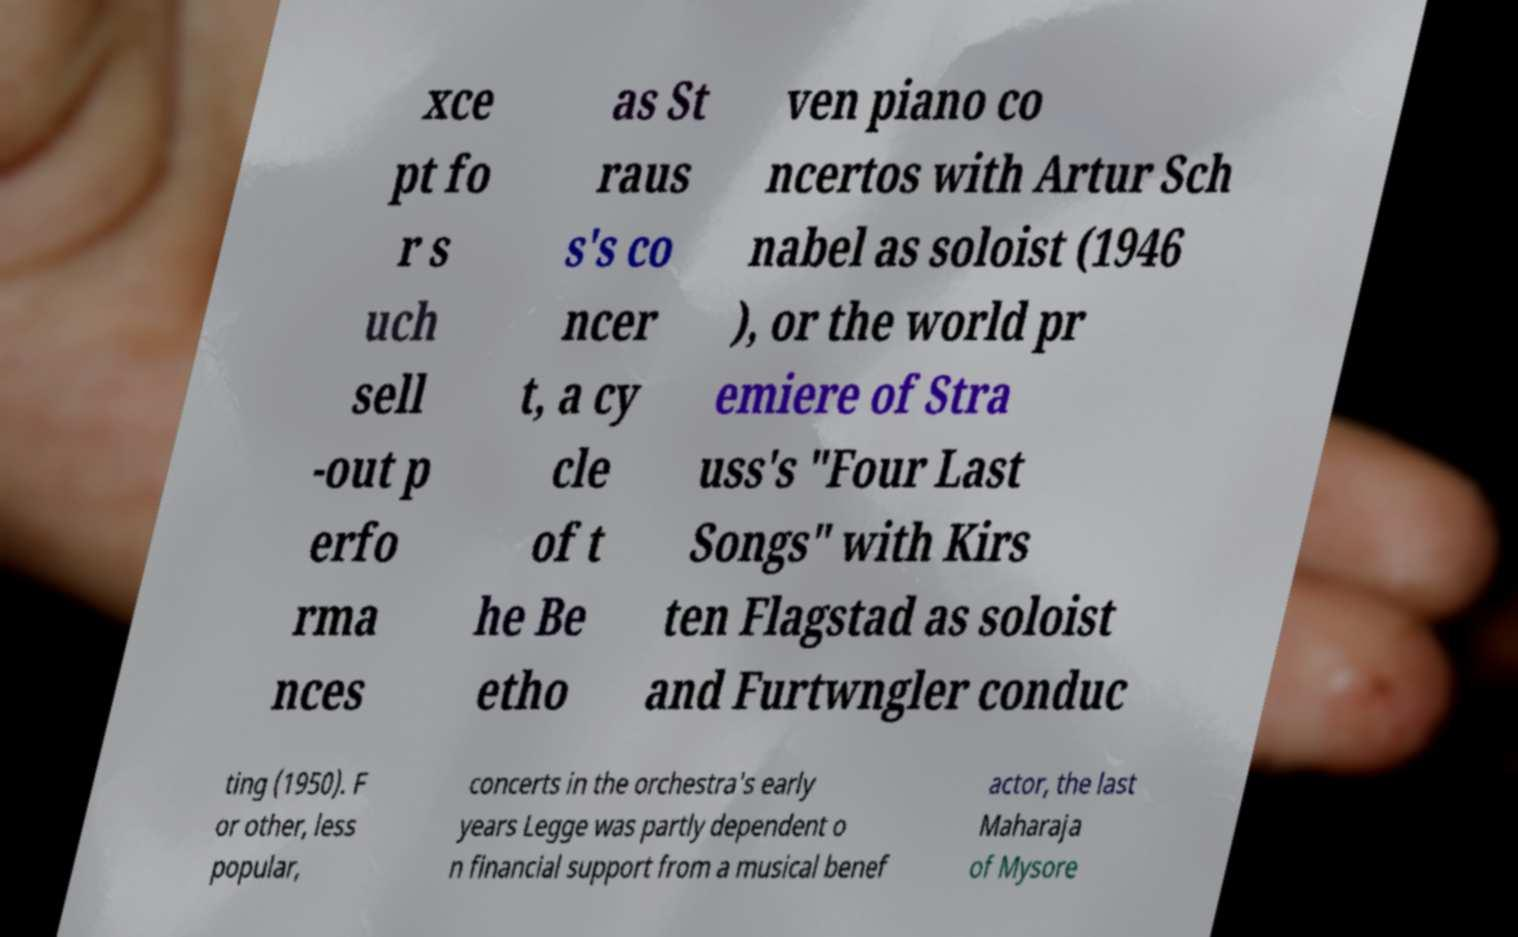There's text embedded in this image that I need extracted. Can you transcribe it verbatim? xce pt fo r s uch sell -out p erfo rma nces as St raus s's co ncer t, a cy cle of t he Be etho ven piano co ncertos with Artur Sch nabel as soloist (1946 ), or the world pr emiere of Stra uss's "Four Last Songs" with Kirs ten Flagstad as soloist and Furtwngler conduc ting (1950). F or other, less popular, concerts in the orchestra's early years Legge was partly dependent o n financial support from a musical benef actor, the last Maharaja of Mysore 